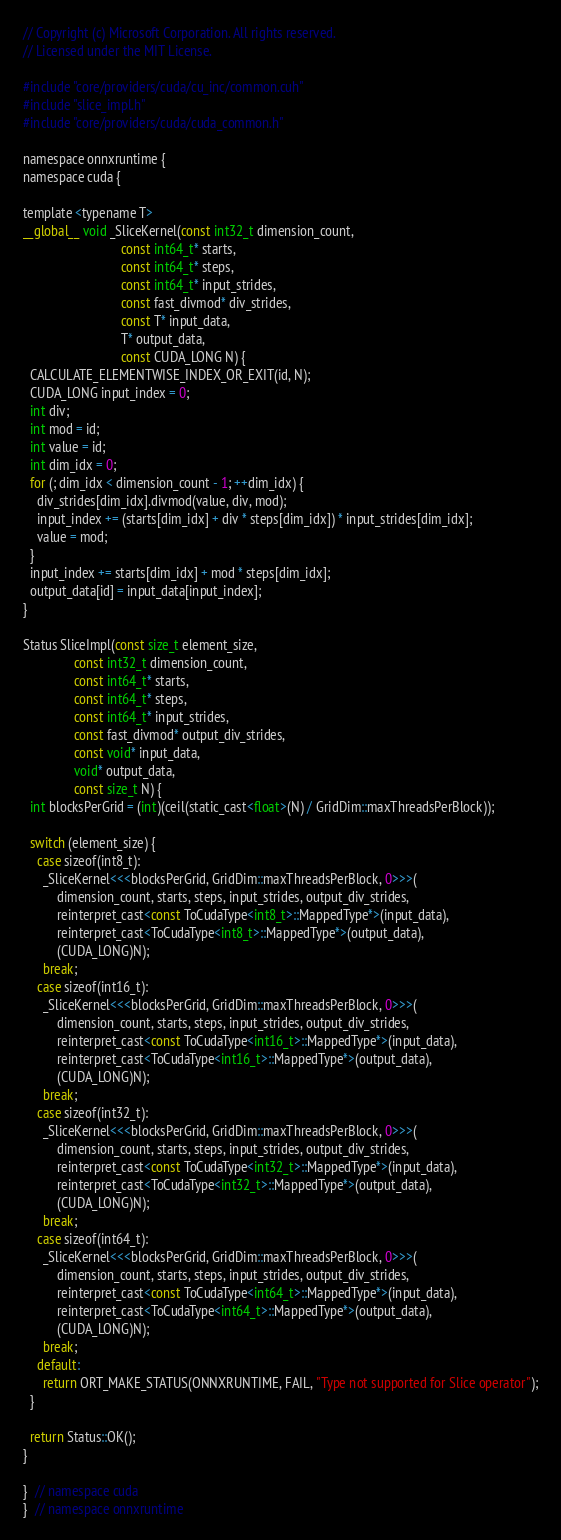<code> <loc_0><loc_0><loc_500><loc_500><_Cuda_>// Copyright (c) Microsoft Corporation. All rights reserved.
// Licensed under the MIT License.

#include "core/providers/cuda/cu_inc/common.cuh"
#include "slice_impl.h"
#include "core/providers/cuda/cuda_common.h"

namespace onnxruntime {
namespace cuda {

template <typename T>
__global__ void _SliceKernel(const int32_t dimension_count,
                             const int64_t* starts,
                             const int64_t* steps,
                             const int64_t* input_strides,
                             const fast_divmod* div_strides,
                             const T* input_data,
                             T* output_data,
                             const CUDA_LONG N) {
  CALCULATE_ELEMENTWISE_INDEX_OR_EXIT(id, N);
  CUDA_LONG input_index = 0;
  int div;
  int mod = id;
  int value = id;
  int dim_idx = 0;
  for (; dim_idx < dimension_count - 1; ++dim_idx) {
    div_strides[dim_idx].divmod(value, div, mod);
    input_index += (starts[dim_idx] + div * steps[dim_idx]) * input_strides[dim_idx];
    value = mod;
  }
  input_index += starts[dim_idx] + mod * steps[dim_idx];
  output_data[id] = input_data[input_index];
}

Status SliceImpl(const size_t element_size,
               const int32_t dimension_count,
               const int64_t* starts,
               const int64_t* steps,
               const int64_t* input_strides,
               const fast_divmod* output_div_strides,
               const void* input_data,
               void* output_data,
               const size_t N) {
  int blocksPerGrid = (int)(ceil(static_cast<float>(N) / GridDim::maxThreadsPerBlock));

  switch (element_size) {
    case sizeof(int8_t):
      _SliceKernel<<<blocksPerGrid, GridDim::maxThreadsPerBlock, 0>>>(
          dimension_count, starts, steps, input_strides, output_div_strides,
          reinterpret_cast<const ToCudaType<int8_t>::MappedType*>(input_data),
          reinterpret_cast<ToCudaType<int8_t>::MappedType*>(output_data),
          (CUDA_LONG)N);
      break;
    case sizeof(int16_t):
      _SliceKernel<<<blocksPerGrid, GridDim::maxThreadsPerBlock, 0>>>(
          dimension_count, starts, steps, input_strides, output_div_strides,
          reinterpret_cast<const ToCudaType<int16_t>::MappedType*>(input_data),
          reinterpret_cast<ToCudaType<int16_t>::MappedType*>(output_data),
          (CUDA_LONG)N);
      break;
    case sizeof(int32_t):
      _SliceKernel<<<blocksPerGrid, GridDim::maxThreadsPerBlock, 0>>>(
          dimension_count, starts, steps, input_strides, output_div_strides,
          reinterpret_cast<const ToCudaType<int32_t>::MappedType*>(input_data),
          reinterpret_cast<ToCudaType<int32_t>::MappedType*>(output_data),
          (CUDA_LONG)N);
      break;
    case sizeof(int64_t):
      _SliceKernel<<<blocksPerGrid, GridDim::maxThreadsPerBlock, 0>>>(
          dimension_count, starts, steps, input_strides, output_div_strides,
          reinterpret_cast<const ToCudaType<int64_t>::MappedType*>(input_data),
          reinterpret_cast<ToCudaType<int64_t>::MappedType*>(output_data),
          (CUDA_LONG)N);
      break;
    default:
      return ORT_MAKE_STATUS(ONNXRUNTIME, FAIL, "Type not supported for Slice operator");
  }

  return Status::OK();
}

}  // namespace cuda
}  // namespace onnxruntime
</code> 